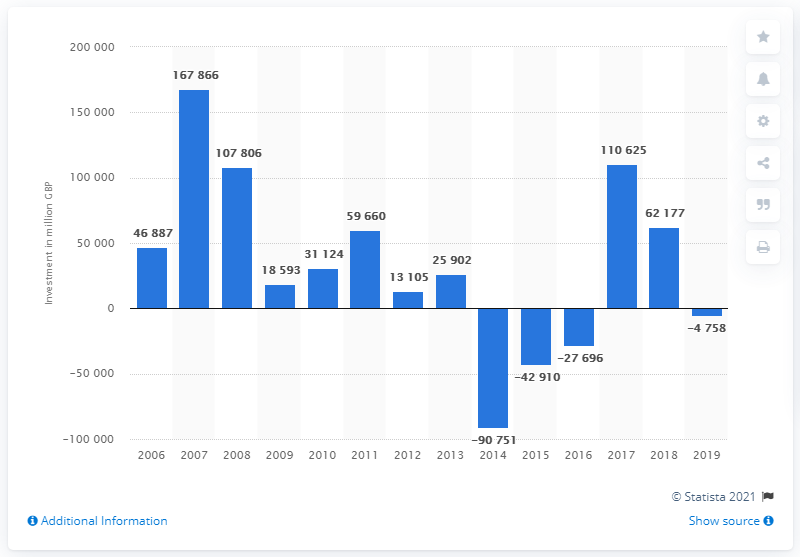Indicate a few pertinent items in this graphic. In 2017, the net foreign direct investment was 110,625. 